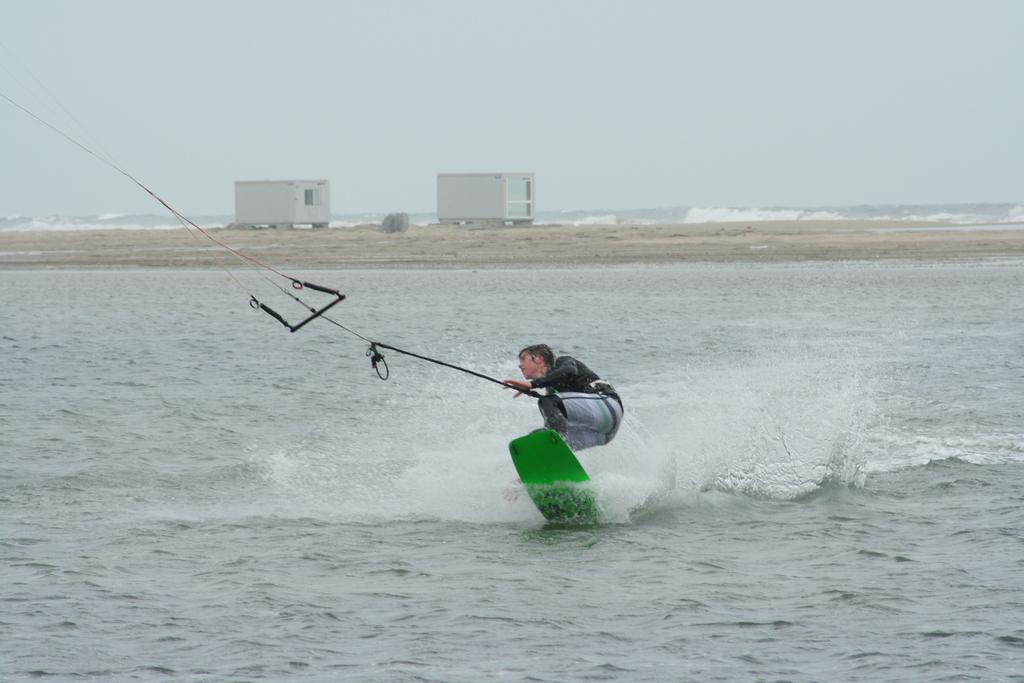What activity is the person in the image engaged in? The person is surfing on the water. How is the person connected to the surfboard? The person is holding a rope with their hand. What objects can be seen in the middle of the image? There are containers in the middle of the image. What is visible at the top of the image? The sky is visible at the top of the image. How many crates are being carried by the brothers in the image? There are no crates or brothers present in the image. What type of yam is being harvested in the image? There is no yam or harvesting activity depicted in the image. 